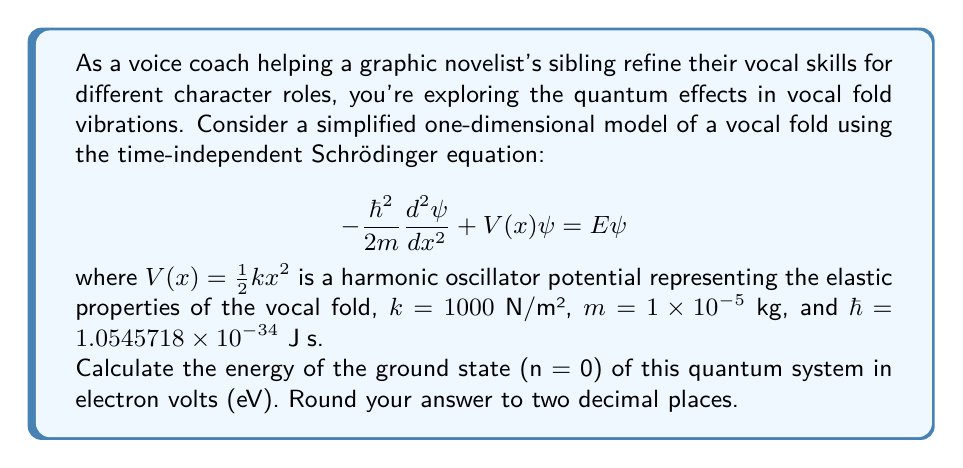Teach me how to tackle this problem. To solve this problem, we'll follow these steps:

1) For a quantum harmonic oscillator, the energy levels are given by:

   $$E_n = \hbar\omega(n + \frac{1}{2})$$

   where $n = 0, 1, 2, ...$, and $\omega$ is the angular frequency of the oscillator.

2) We need to find $\omega$. For a classical harmonic oscillator:

   $$\omega = \sqrt{\frac{k}{m}}$$

3) Let's calculate $\omega$:

   $$\omega = \sqrt{\frac{1000 \text{ N/m²}}{1 \times 10^{-5} \text{ kg}}} = 10^4 \text{ rad/s}$$

4) Now we can calculate the ground state energy (n = 0):

   $$E_0 = \frac{1}{2}\hbar\omega$$

5) Substituting the values:

   $$E_0 = \frac{1}{2} \times 1.0545718 \times 10^{-34} \text{ J⋅s} \times 10^4 \text{ rad/s}$$

   $$E_0 = 5.272859 \times 10^{-31} \text{ J}$$

6) Convert joules to electron volts:
   1 eV = $1.602176634 \times 10^{-19}$ J

   $$E_0 \text{ in eV} = \frac{5.272859 \times 10^{-31} \text{ J}}{1.602176634 \times 10^{-19} \text{ J/eV}} = 3.29109 \times 10^{-12} \text{ eV}$$

7) Rounding to two decimal places:

   $$E_0 \approx 3.29 \times 10^{-12} \text{ eV}$$
Answer: $3.29 \times 10^{-12} \text{ eV}$ 